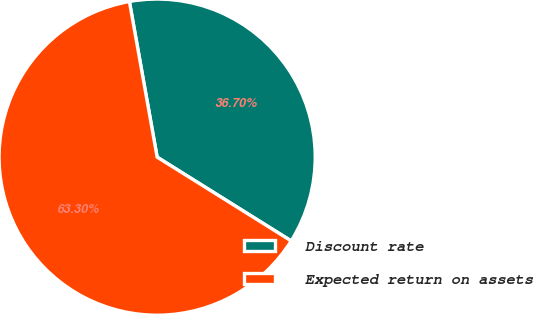Convert chart. <chart><loc_0><loc_0><loc_500><loc_500><pie_chart><fcel>Discount rate<fcel>Expected return on assets<nl><fcel>36.7%<fcel>63.3%<nl></chart> 